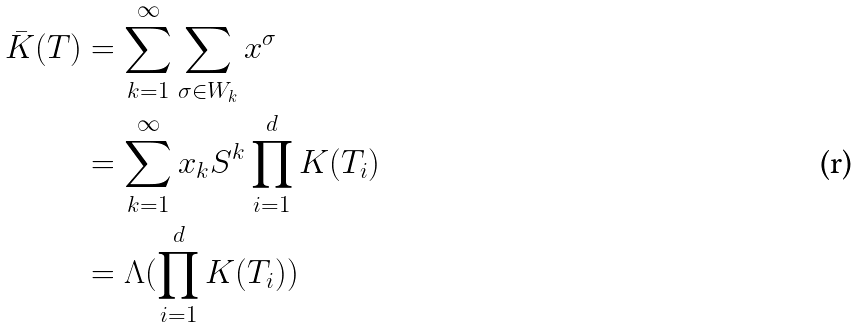Convert formula to latex. <formula><loc_0><loc_0><loc_500><loc_500>\bar { K } ( T ) & = \sum _ { k = 1 } ^ { \infty } \sum _ { \sigma \in W _ { k } } x ^ { \sigma } \\ & = \sum _ { k = 1 } ^ { \infty } x _ { k } S ^ { k } \prod _ { i = 1 } ^ { d } K ( T _ { i } ) \\ & = \Lambda ( \prod _ { i = 1 } ^ { d } K ( T _ { i } ) )</formula> 